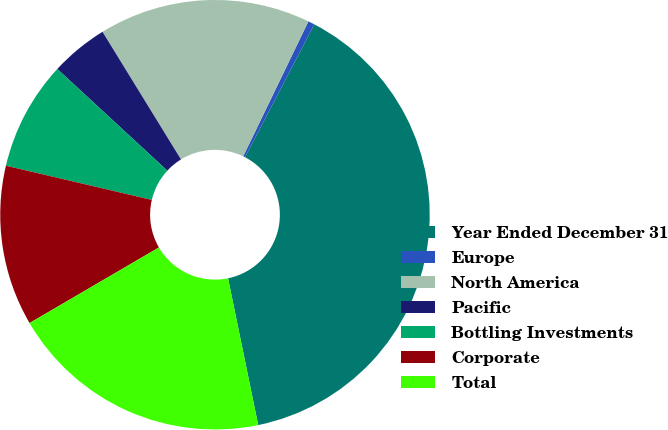Convert chart. <chart><loc_0><loc_0><loc_500><loc_500><pie_chart><fcel>Year Ended December 31<fcel>Europe<fcel>North America<fcel>Pacific<fcel>Bottling Investments<fcel>Corporate<fcel>Total<nl><fcel>39.12%<fcel>0.49%<fcel>15.94%<fcel>4.35%<fcel>8.21%<fcel>12.08%<fcel>19.81%<nl></chart> 